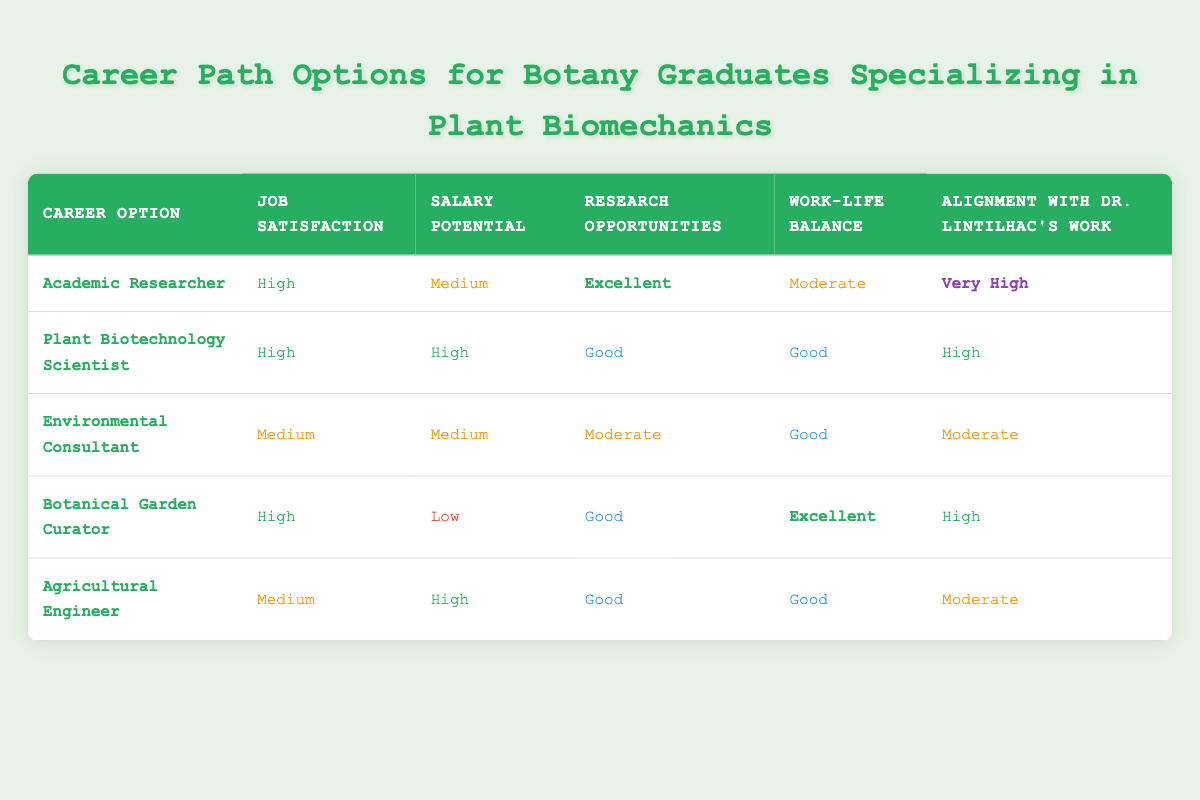What is the job satisfaction level for the Botanical Garden Curator? The table shows that the job satisfaction for the Botanical Garden Curator is classified as "High."
Answer: High Which career option has the highest salary potential? According to the table, both the Plant Biotechnology Scientist and Agricultural Engineer have a salary potential classified as "High," which is the highest of all the options listed.
Answer: Plant Biotechnology Scientist and Agricultural Engineer How many career options have a "Good" rating for research opportunities? The table lists three career options that have a "Good" rating for research opportunities: Plant Biotechnology Scientist, Environmental Consultant, and Agricultural Engineer.
Answer: Three Is the alignment with Dr. Lintilhac's work "Very High" for any other career options besides Academic Researcher? The table shows that only the Academic Researcher has an alignment with Dr. Lintilhac's work rated as "Very High." All other options have lower ratings, indicating the answer is no.
Answer: No What is the difference in job satisfaction between Agricultural Engineer and Botanical Garden Curator? The job satisfaction for Agricultural Engineer is "Medium" and for Botanical Garden Curator is "High." The difference is one level higher for Botanical Garden Curator compared to Agricultural Engineer.
Answer: One level Which career option has the best work-life balance? The Botanical Garden Curator has an "Excellent" rating for work-life balance, which is the highest among all the options listed in the table.
Answer: Botanical Garden Curator How would you characterize the research opportunities for Environmental Consultant in comparison to the other job options? The Environmental Consultant has "Moderate" research opportunities, which is lower than the "Good" ratings of Plant Biotechnology Scientist, Botanical Garden Curator, and Agricultural Engineer, and lower than the "Excellent" of Academic Researcher. Therefore, it is characterized as below average compared to other options.
Answer: Below average Are any career options rated "Low" for salary potential? Yes, the table shows that the Botanical Garden Curator is rated "Low" for salary potential.
Answer: Yes 